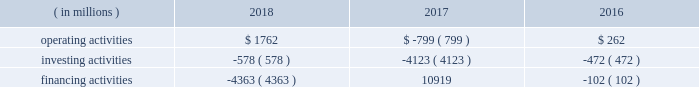Bhge 2018 form 10-k | 39 outstanding under the commercial paper program .
The maximum combined borrowing at any time under both the 2017 credit agreement and the commercial paper program is $ 3 billion .
If market conditions were to change and our revenue was reduced significantly or operating costs were to increase , our cash flows and liquidity could be reduced .
Additionally , it could cause the rating agencies to lower our credit rating .
There are no ratings triggers that would accelerate the maturity of any borrowings under our committed credit facility .
However , a downgrade in our credit ratings could increase the cost of borrowings under the credit facility and could also limit or preclude our ability to issue commercial paper .
Should this occur , we could seek alternative sources of funding , including borrowing under the credit facility .
During the year ended december 31 , 2018 , we used cash to fund a variety of activities including certain working capital needs and restructuring costs , capital expenditures , the repayment of debt , payment of dividends , distributions to ge and share repurchases .
We believe that cash on hand , cash flows generated from operations and the available credit facility will provide sufficient liquidity to manage our global cash needs .
Cash flows cash flows provided by ( used in ) each type of activity were as follows for the years ended december 31: .
Operating activities our largest source of operating cash is payments from customers , of which the largest component is collecting cash related to product or services sales including advance payments or progress collections for work to be performed .
The primary use of operating cash is to pay our suppliers , employees , tax authorities and others for a wide range of material and services .
Cash flows from operating activities generated cash of $ 1762 million and used cash of $ 799 million for the years ended december 31 , 2018 and 2017 , respectively .
Cash flows from operating activities increased $ 2561 million in 2018 primarily driven by better operating performance .
These cash inflows were supported by strong working capital cash flows , especially in the fourth quarter of 2018 , including approximately $ 300 million for a progress collection payment from a customer .
Included in our cash flows from operating activities for 2018 and 2017 are payments of $ 473 million and $ 612 million , respectively , made primarily for employee severance as a result of our restructuring activities and merger and related costs .
Cash flows from operating activities used $ 799 million and generated $ 262 million for the years ended december 31 , 2017 and 2016 , respectively .
Cash flows from operating activities decreased $ 1061 million in 2017 primarily driven by a $ 1201 million negative impact from ending our receivables monetization program in the fourth quarter , and restructuring related payments throughout the year .
These cash outflows were partially offset by strong working capital cash flows , especially in the fourth quarter of 2017 .
Included in our cash flows from operating activities for 2017 and 2016 are payments of $ 612 million and $ 177 million , respectively , made for employee severance as a result of our restructuring activities and merger and related costs .
Investing activities cash flows from investing activities used cash of $ 578 million , $ 4123 million and $ 472 million for the years ended december 31 , 2018 , 2017 and 2016 , respectively .
Our principal recurring investing activity is the funding of capital expenditures to ensure that we have the appropriate levels and types of machinery and equipment in place to generate revenue from operations .
Expenditures for capital assets totaled $ 995 million , $ 665 million and $ 424 million for 2018 , 2017 and 2016 , respectively , partially offset by cash flows from the sale of property , plant and equipment of $ 458 million , $ 172 million and $ 20 million in 2018 , 2017 and 2016 , respectively .
Proceeds from the disposal of assets related primarily .
What are the expenditures for capital assets in 2018 as a percentage of cash from operating activities in 2018? 
Computations: (995 / 1762)
Answer: 0.5647. Bhge 2018 form 10-k | 39 outstanding under the commercial paper program .
The maximum combined borrowing at any time under both the 2017 credit agreement and the commercial paper program is $ 3 billion .
If market conditions were to change and our revenue was reduced significantly or operating costs were to increase , our cash flows and liquidity could be reduced .
Additionally , it could cause the rating agencies to lower our credit rating .
There are no ratings triggers that would accelerate the maturity of any borrowings under our committed credit facility .
However , a downgrade in our credit ratings could increase the cost of borrowings under the credit facility and could also limit or preclude our ability to issue commercial paper .
Should this occur , we could seek alternative sources of funding , including borrowing under the credit facility .
During the year ended december 31 , 2018 , we used cash to fund a variety of activities including certain working capital needs and restructuring costs , capital expenditures , the repayment of debt , payment of dividends , distributions to ge and share repurchases .
We believe that cash on hand , cash flows generated from operations and the available credit facility will provide sufficient liquidity to manage our global cash needs .
Cash flows cash flows provided by ( used in ) each type of activity were as follows for the years ended december 31: .
Operating activities our largest source of operating cash is payments from customers , of which the largest component is collecting cash related to product or services sales including advance payments or progress collections for work to be performed .
The primary use of operating cash is to pay our suppliers , employees , tax authorities and others for a wide range of material and services .
Cash flows from operating activities generated cash of $ 1762 million and used cash of $ 799 million for the years ended december 31 , 2018 and 2017 , respectively .
Cash flows from operating activities increased $ 2561 million in 2018 primarily driven by better operating performance .
These cash inflows were supported by strong working capital cash flows , especially in the fourth quarter of 2018 , including approximately $ 300 million for a progress collection payment from a customer .
Included in our cash flows from operating activities for 2018 and 2017 are payments of $ 473 million and $ 612 million , respectively , made primarily for employee severance as a result of our restructuring activities and merger and related costs .
Cash flows from operating activities used $ 799 million and generated $ 262 million for the years ended december 31 , 2017 and 2016 , respectively .
Cash flows from operating activities decreased $ 1061 million in 2017 primarily driven by a $ 1201 million negative impact from ending our receivables monetization program in the fourth quarter , and restructuring related payments throughout the year .
These cash outflows were partially offset by strong working capital cash flows , especially in the fourth quarter of 2017 .
Included in our cash flows from operating activities for 2017 and 2016 are payments of $ 612 million and $ 177 million , respectively , made for employee severance as a result of our restructuring activities and merger and related costs .
Investing activities cash flows from investing activities used cash of $ 578 million , $ 4123 million and $ 472 million for the years ended december 31 , 2018 , 2017 and 2016 , respectively .
Our principal recurring investing activity is the funding of capital expenditures to ensure that we have the appropriate levels and types of machinery and equipment in place to generate revenue from operations .
Expenditures for capital assets totaled $ 995 million , $ 665 million and $ 424 million for 2018 , 2017 and 2016 , respectively , partially offset by cash flows from the sale of property , plant and equipment of $ 458 million , $ 172 million and $ 20 million in 2018 , 2017 and 2016 , respectively .
Proceeds from the disposal of assets related primarily .
What is the net change in cash during 2017? 
Computations: ((-799 + -4123) + 10919)
Answer: 5997.0. Bhge 2018 form 10-k | 39 outstanding under the commercial paper program .
The maximum combined borrowing at any time under both the 2017 credit agreement and the commercial paper program is $ 3 billion .
If market conditions were to change and our revenue was reduced significantly or operating costs were to increase , our cash flows and liquidity could be reduced .
Additionally , it could cause the rating agencies to lower our credit rating .
There are no ratings triggers that would accelerate the maturity of any borrowings under our committed credit facility .
However , a downgrade in our credit ratings could increase the cost of borrowings under the credit facility and could also limit or preclude our ability to issue commercial paper .
Should this occur , we could seek alternative sources of funding , including borrowing under the credit facility .
During the year ended december 31 , 2018 , we used cash to fund a variety of activities including certain working capital needs and restructuring costs , capital expenditures , the repayment of debt , payment of dividends , distributions to ge and share repurchases .
We believe that cash on hand , cash flows generated from operations and the available credit facility will provide sufficient liquidity to manage our global cash needs .
Cash flows cash flows provided by ( used in ) each type of activity were as follows for the years ended december 31: .
Operating activities our largest source of operating cash is payments from customers , of which the largest component is collecting cash related to product or services sales including advance payments or progress collections for work to be performed .
The primary use of operating cash is to pay our suppliers , employees , tax authorities and others for a wide range of material and services .
Cash flows from operating activities generated cash of $ 1762 million and used cash of $ 799 million for the years ended december 31 , 2018 and 2017 , respectively .
Cash flows from operating activities increased $ 2561 million in 2018 primarily driven by better operating performance .
These cash inflows were supported by strong working capital cash flows , especially in the fourth quarter of 2018 , including approximately $ 300 million for a progress collection payment from a customer .
Included in our cash flows from operating activities for 2018 and 2017 are payments of $ 473 million and $ 612 million , respectively , made primarily for employee severance as a result of our restructuring activities and merger and related costs .
Cash flows from operating activities used $ 799 million and generated $ 262 million for the years ended december 31 , 2017 and 2016 , respectively .
Cash flows from operating activities decreased $ 1061 million in 2017 primarily driven by a $ 1201 million negative impact from ending our receivables monetization program in the fourth quarter , and restructuring related payments throughout the year .
These cash outflows were partially offset by strong working capital cash flows , especially in the fourth quarter of 2017 .
Included in our cash flows from operating activities for 2017 and 2016 are payments of $ 612 million and $ 177 million , respectively , made for employee severance as a result of our restructuring activities and merger and related costs .
Investing activities cash flows from investing activities used cash of $ 578 million , $ 4123 million and $ 472 million for the years ended december 31 , 2018 , 2017 and 2016 , respectively .
Our principal recurring investing activity is the funding of capital expenditures to ensure that we have the appropriate levels and types of machinery and equipment in place to generate revenue from operations .
Expenditures for capital assets totaled $ 995 million , $ 665 million and $ 424 million for 2018 , 2017 and 2016 , respectively , partially offset by cash flows from the sale of property , plant and equipment of $ 458 million , $ 172 million and $ 20 million in 2018 , 2017 and 2016 , respectively .
Proceeds from the disposal of assets related primarily .
What is the net change in cash during 2018? 
Computations: ((1762 + -578) + -4363)
Answer: -3179.0. 